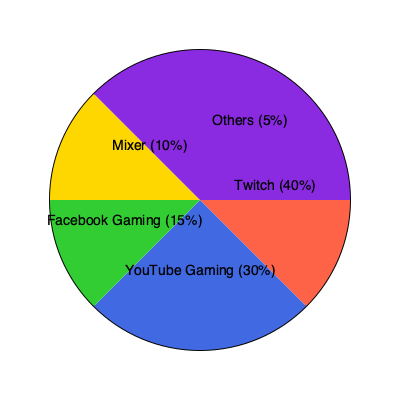Based on the pie chart depicting market share of different streaming platforms, what is the ratio of Twitch's market share to the combined market share of Facebook Gaming and Mixer? To solve this problem, we need to follow these steps:

1. Identify the market shares:
   - Twitch: 40%
   - Facebook Gaming: 15%
   - Mixer: 10%

2. Calculate the combined market share of Facebook Gaming and Mixer:
   $15\% + 10\% = 25\%$

3. Set up the ratio of Twitch's market share to the combined share:
   $\frac{\text{Twitch's share}}{\text{Facebook Gaming + Mixer share}} = \frac{40\%}{25\%}$

4. Simplify the ratio:
   $\frac{40}{25} = \frac{8}{5} = 1.6:1$

Therefore, the ratio of Twitch's market share to the combined market share of Facebook Gaming and Mixer is 8:5 or 1.6:1.
Answer: 8:5 